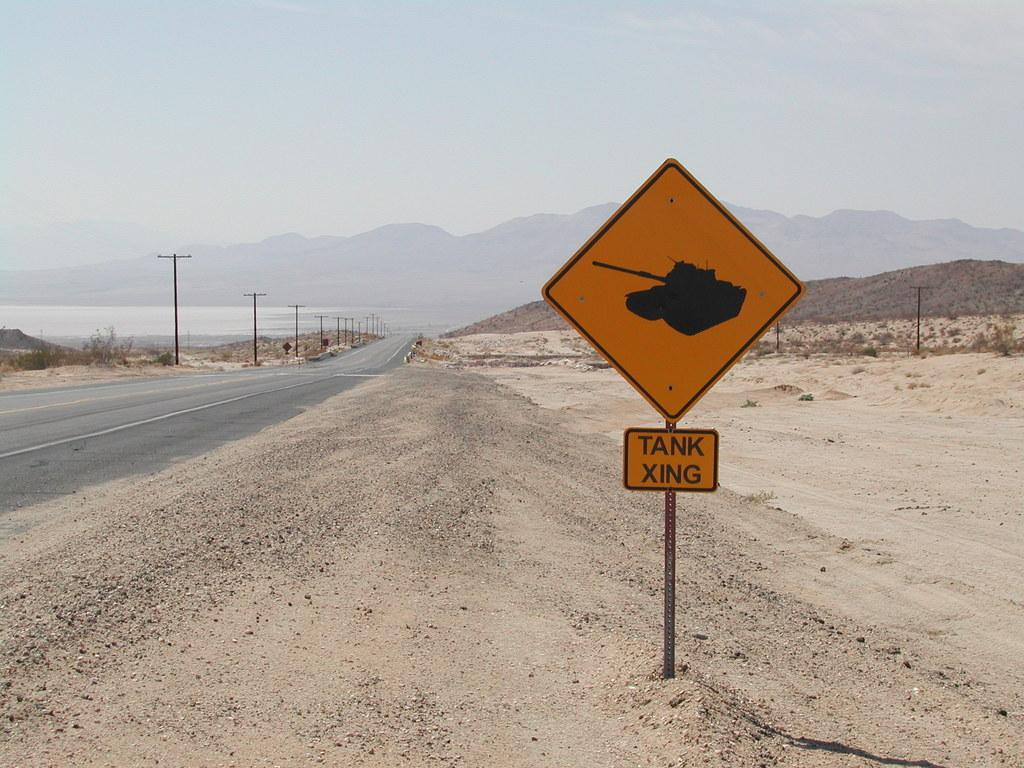<image>
Relay a brief, clear account of the picture shown. A desert highway has a yellow sign that says Tank Xing. 